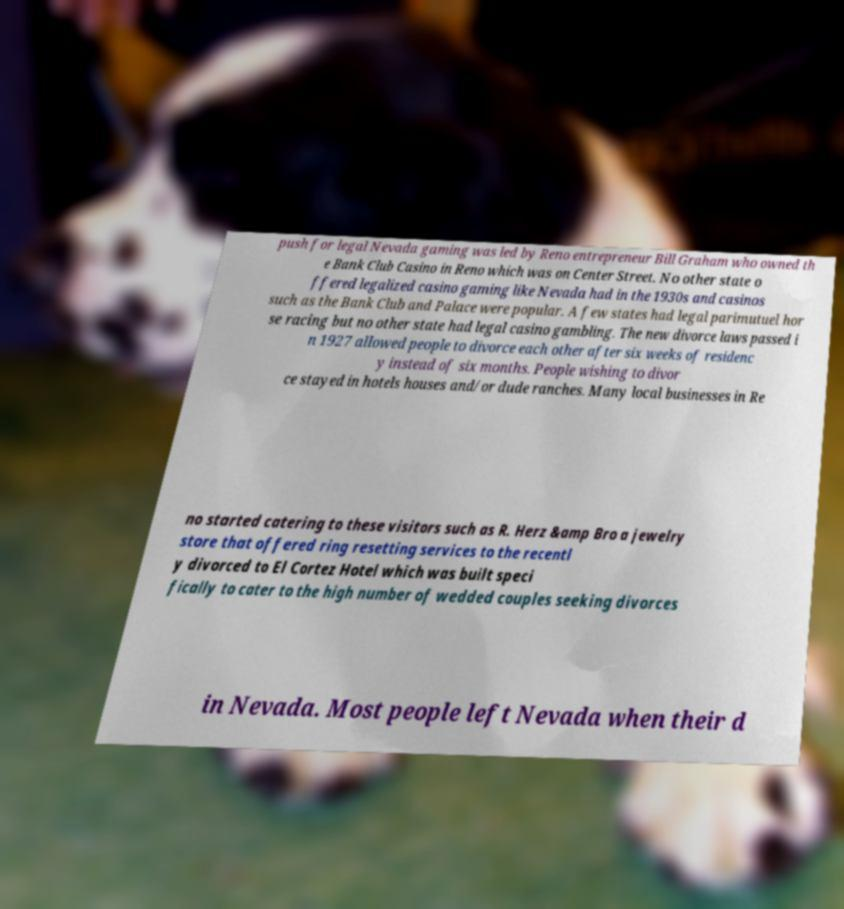For documentation purposes, I need the text within this image transcribed. Could you provide that? push for legal Nevada gaming was led by Reno entrepreneur Bill Graham who owned th e Bank Club Casino in Reno which was on Center Street. No other state o ffered legalized casino gaming like Nevada had in the 1930s and casinos such as the Bank Club and Palace were popular. A few states had legal parimutuel hor se racing but no other state had legal casino gambling. The new divorce laws passed i n 1927 allowed people to divorce each other after six weeks of residenc y instead of six months. People wishing to divor ce stayed in hotels houses and/or dude ranches. Many local businesses in Re no started catering to these visitors such as R. Herz &amp Bro a jewelry store that offered ring resetting services to the recentl y divorced to El Cortez Hotel which was built speci fically to cater to the high number of wedded couples seeking divorces in Nevada. Most people left Nevada when their d 